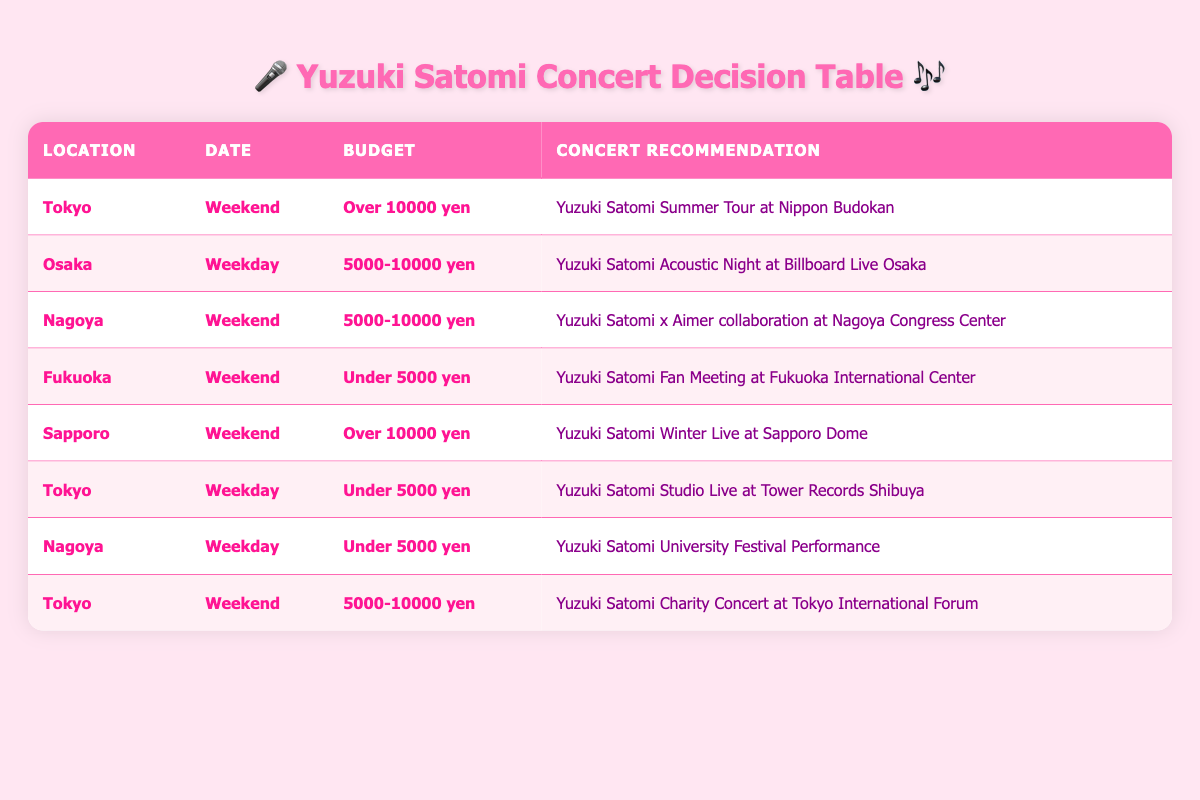What concert can I attend in Tokyo on a weekend with a budget over 10000 yen? In the table, I look for the row where the location is Tokyo, the date is Weekend, and the budget is Over 10000 yen. The corresponding concert recommendation is "Yuzuki Satomi Summer Tour at Nippon Budokan."
Answer: Yuzuki Satomi Summer Tour at Nippon Budokan Which concert is recommended in Fukuoka for a weekend with a budget under 5000 yen? Upon checking the table, the row for Fukuoka is needed, with the Date as Weekend and Budget under 5000 yen. It shows "Yuzuki Satomi Fan Meeting at Fukuoka International Center."
Answer: Yuzuki Satomi Fan Meeting at Fukuoka International Center Is there a concert in Sapporo on a weekend that costs over 10000 yen? The Sapporo row is checked and it shows a concert on the Weekend and Budget Over 10000 yen. It is indeed true that there is a concert in Sapporo for this criteria: "Yuzuki Satomi Winter Live at Sapporo Dome."
Answer: Yes What are the concert recommendations for Nagoya on a weekday with a budget under 5000 yen? I review the rows regarding Nagoya and check for the Date as Weekday and Budget under 5000 yen. The table indicates the concert recommendation is "Yuzuki Satomi University Festival Performance."
Answer: Yuzuki Satomi University Festival Performance How many concerts are recommended on weekends that have a budget of 5000-10000 yen? In the table, I count the rows where the Date is Weekend and Budget is 5000-10000 yen. There are two rows matching this criteria: "Yuzuki Satomi x Aimer collaboration at Nagoya Congress Center" and "Yuzuki Satomi Charity Concert at Tokyo International Forum." Thus, the total count is 2.
Answer: 2 Are there any concerts on weekday in Tokyo that are under 5000 yen? Checking the table for Tokyo on a weekday under 5000 yen shows that "Yuzuki Satomi Studio Live at Tower Records Shibuya" is indeed recommended.
Answer: Yes What is the concert recommendation in Osaka with a budget between 5000-10000 yen? I examine the Osaka row in the table for a budget within 5000-10000 yen and find the recommendation is "Yuzuki Satomi Acoustic Night at Billboard Live Osaka."
Answer: Yuzuki Satomi Acoustic Night at Billboard Live Osaka Which cities have concerts on weekends with a budget under 5000 yen? To find the cities, I look at all Weekend concerts with a budget Under 5000 yen in the table. Only Fukuoka meets this requirement with "Yuzuki Satomi Fan Meeting at Fukuoka International Center."
Answer: Fukuoka What is the average budget range for concerts in Tokyo on weekends? Assessing the table, I look for all Tokyo concert recommendations on weekends. There are three applicable recommendations with budgets of Over 10000 yen, 5000-10000 yen, and the criterion includes averaging across these budgets. The average range (considering various ranges provided) leads to an approximation therefore the average is 5,000 to over 10,000 yen.
Answer: Approximately 5,000 to over 10,000 yen 